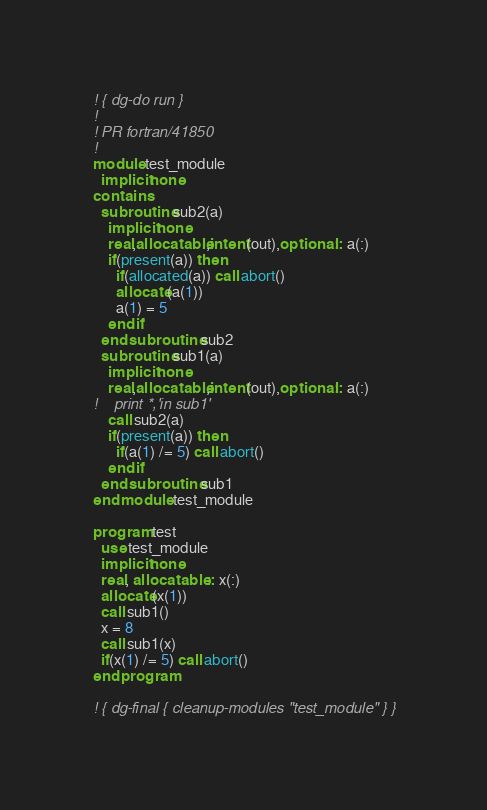Convert code to text. <code><loc_0><loc_0><loc_500><loc_500><_FORTRAN_>! { dg-do run }
!
! PR fortran/41850
!
module test_module
  implicit none
contains
  subroutine sub2(a)
    implicit none
    real,allocatable,intent(out),optional :: a(:)
    if(present(a)) then
      if(allocated(a)) call abort()
      allocate(a(1))
      a(1) = 5
    end if
  end subroutine sub2
  subroutine sub1(a)
    implicit none
    real,allocatable,intent(out),optional :: a(:)
!    print *,'in sub1'
    call sub2(a)
    if(present(a)) then
      if(a(1) /= 5) call abort()
    end if
  end subroutine sub1
end module test_module

program test
  use test_module
  implicit none
  real, allocatable :: x(:)
  allocate(x(1))
  call sub1()
  x = 8
  call sub1(x)
  if(x(1) /= 5) call abort()
end program

! { dg-final { cleanup-modules "test_module" } }
</code> 